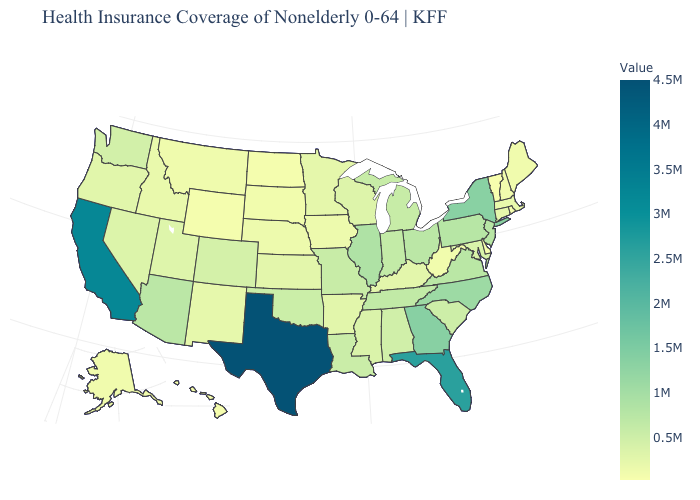Among the states that border North Carolina , does South Carolina have the highest value?
Give a very brief answer. No. Does Florida have a lower value than Kansas?
Concise answer only. No. Which states have the lowest value in the USA?
Be succinct. Vermont. Does Minnesota have the highest value in the MidWest?
Write a very short answer. No. Does Texas have the highest value in the USA?
Be succinct. Yes. Does Virginia have a higher value than New York?
Answer briefly. No. Among the states that border Oklahoma , which have the lowest value?
Be succinct. New Mexico. 